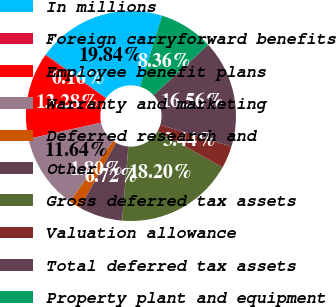<chart> <loc_0><loc_0><loc_500><loc_500><pie_chart><fcel>In millions<fcel>Foreign carryforward benefits<fcel>Employee benefit plans<fcel>Warranty and marketing<fcel>Deferred research and<fcel>Other<fcel>Gross deferred tax assets<fcel>Valuation allowance<fcel>Total deferred tax assets<fcel>Property plant and equipment<nl><fcel>19.84%<fcel>0.16%<fcel>13.28%<fcel>11.64%<fcel>1.8%<fcel>6.72%<fcel>18.2%<fcel>3.44%<fcel>16.56%<fcel>8.36%<nl></chart> 